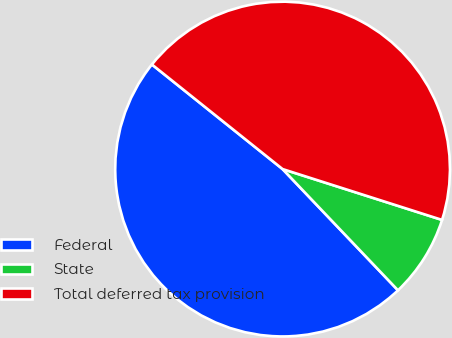Convert chart. <chart><loc_0><loc_0><loc_500><loc_500><pie_chart><fcel>Federal<fcel>State<fcel>Total deferred tax provision<nl><fcel>47.85%<fcel>7.98%<fcel>44.17%<nl></chart> 